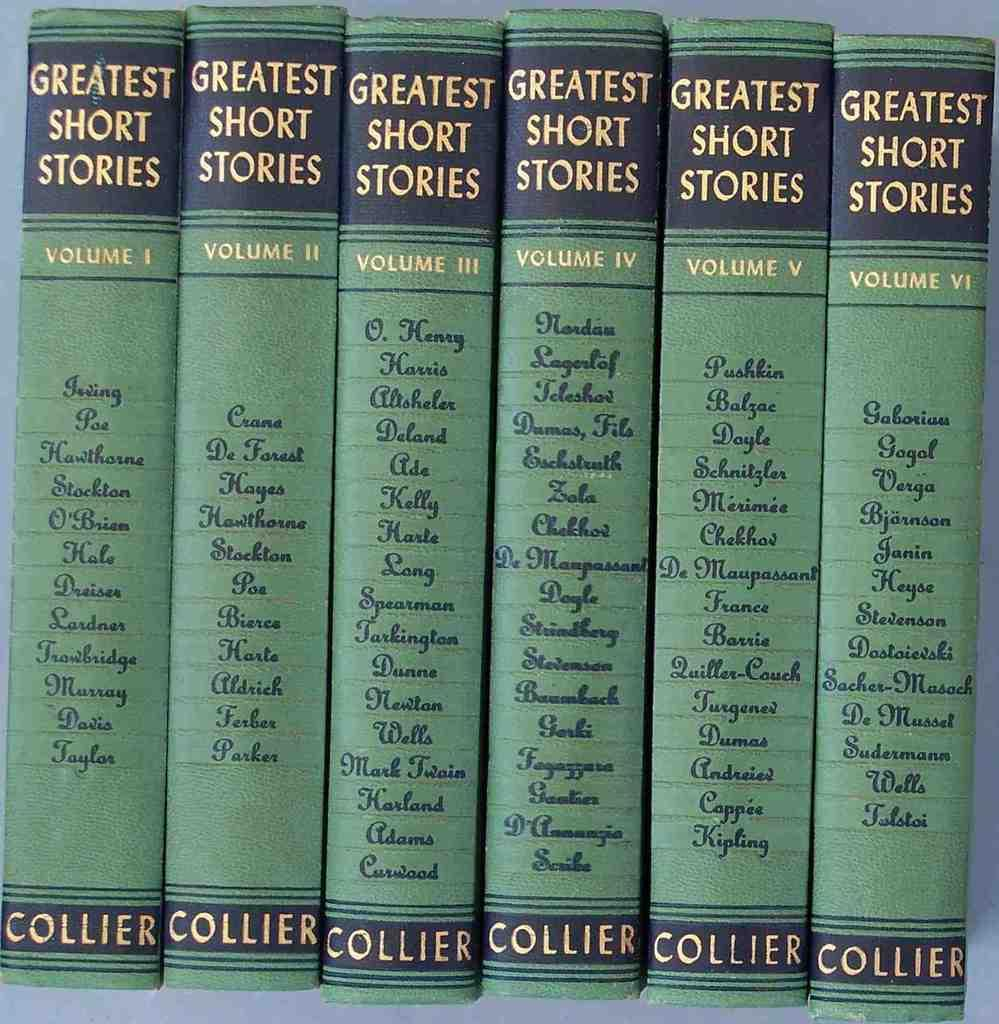<image>
Summarize the visual content of the image. Six greatest short stories books by Collier are side by side. 